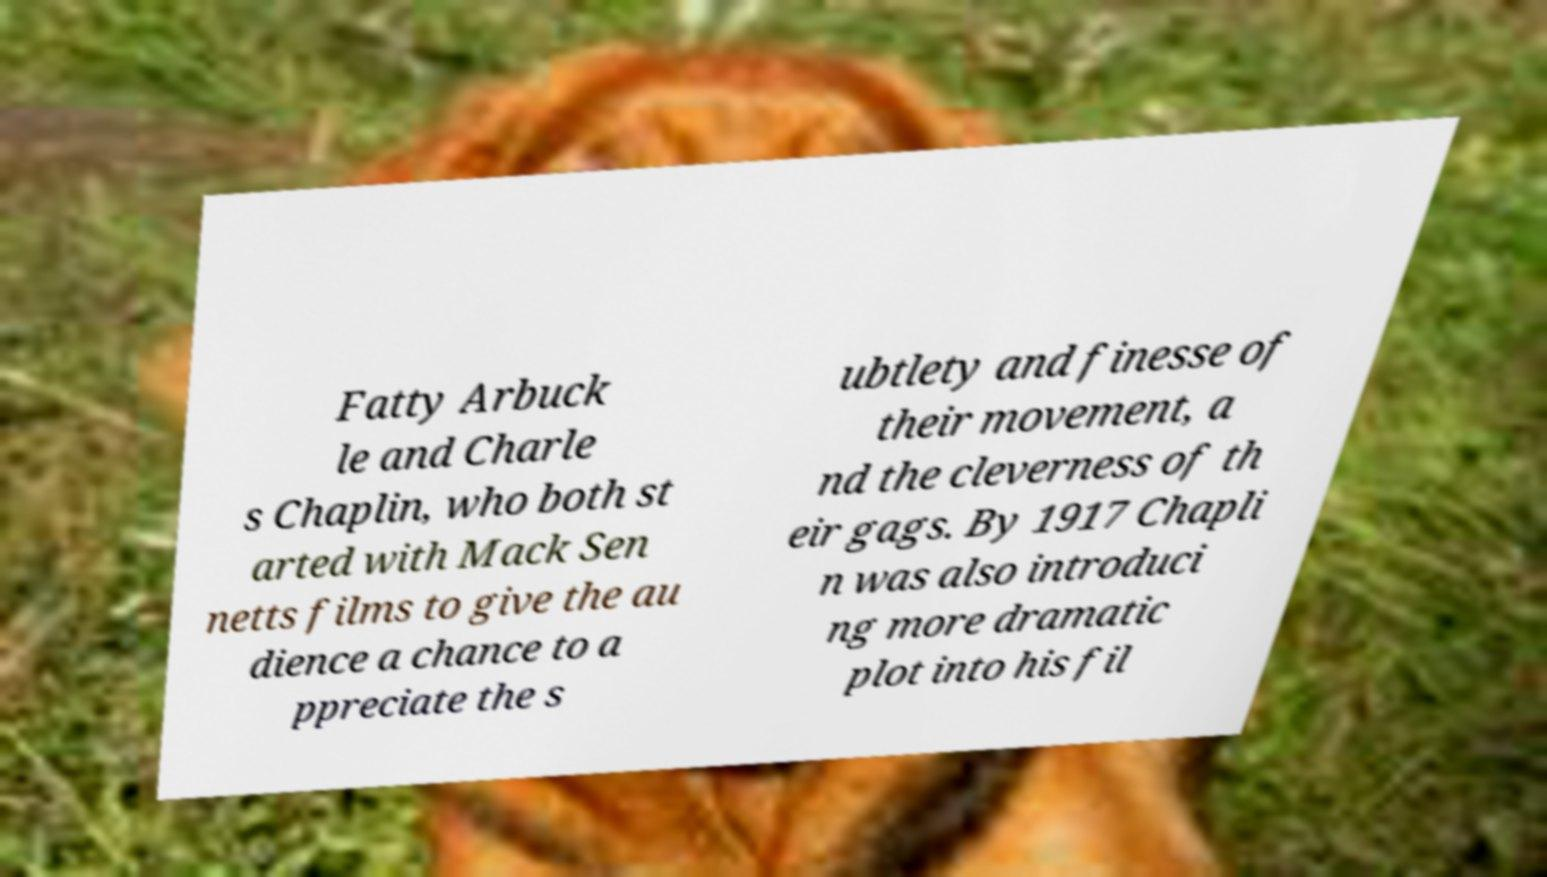For documentation purposes, I need the text within this image transcribed. Could you provide that? Fatty Arbuck le and Charle s Chaplin, who both st arted with Mack Sen netts films to give the au dience a chance to a ppreciate the s ubtlety and finesse of their movement, a nd the cleverness of th eir gags. By 1917 Chapli n was also introduci ng more dramatic plot into his fil 